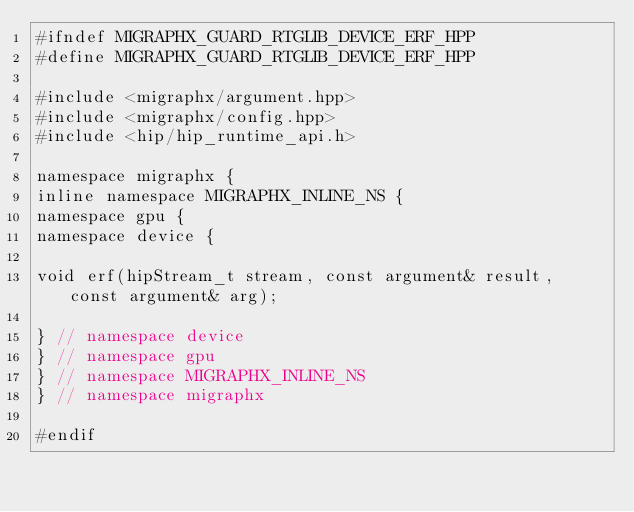<code> <loc_0><loc_0><loc_500><loc_500><_C++_>#ifndef MIGRAPHX_GUARD_RTGLIB_DEVICE_ERF_HPP
#define MIGRAPHX_GUARD_RTGLIB_DEVICE_ERF_HPP

#include <migraphx/argument.hpp>
#include <migraphx/config.hpp>
#include <hip/hip_runtime_api.h>

namespace migraphx {
inline namespace MIGRAPHX_INLINE_NS {
namespace gpu {
namespace device {

void erf(hipStream_t stream, const argument& result, const argument& arg);

} // namespace device
} // namespace gpu
} // namespace MIGRAPHX_INLINE_NS
} // namespace migraphx

#endif
</code> 